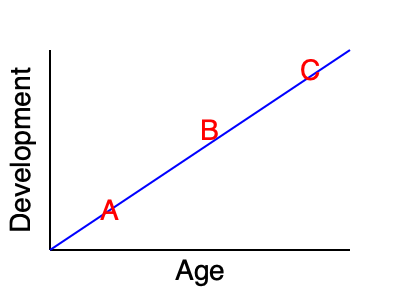In the child development growth chart above, which stage (A, B, or C) represents the period of most rapid growth and why is this stage particularly crucial for children who have experienced trauma? To answer this question, we need to analyze the growth chart and understand the stages of child development:

1. The chart shows a curve representing child development over time (age).
2. The steepness of the curve indicates the rate of development.
3. Stage A (early childhood) shows the steepest curve, indicating the most rapid growth.
4. Stage B (middle childhood) shows a slower rate of growth.
5. Stage C (adolescence) shows the slowest rate of growth.

Stage A is particularly crucial for children who have experienced trauma because:

1. Early childhood is a period of rapid brain development and neuroplasticity.
2. Experiences during this stage have a significant impact on future development.
3. Trauma during this stage can disrupt normal developmental processes.
4. Interventions and support during this stage can be most effective in mitigating the effects of trauma.
5. Creating a safe and joyful environment during this stage can help rebuild trust and promote healthy attachment.

Understanding this stage is vital for social workers to provide appropriate interventions and support for trauma-impacted children.
Answer: Stage A; rapid brain development and high neuroplasticity make it crucial for trauma intervention. 